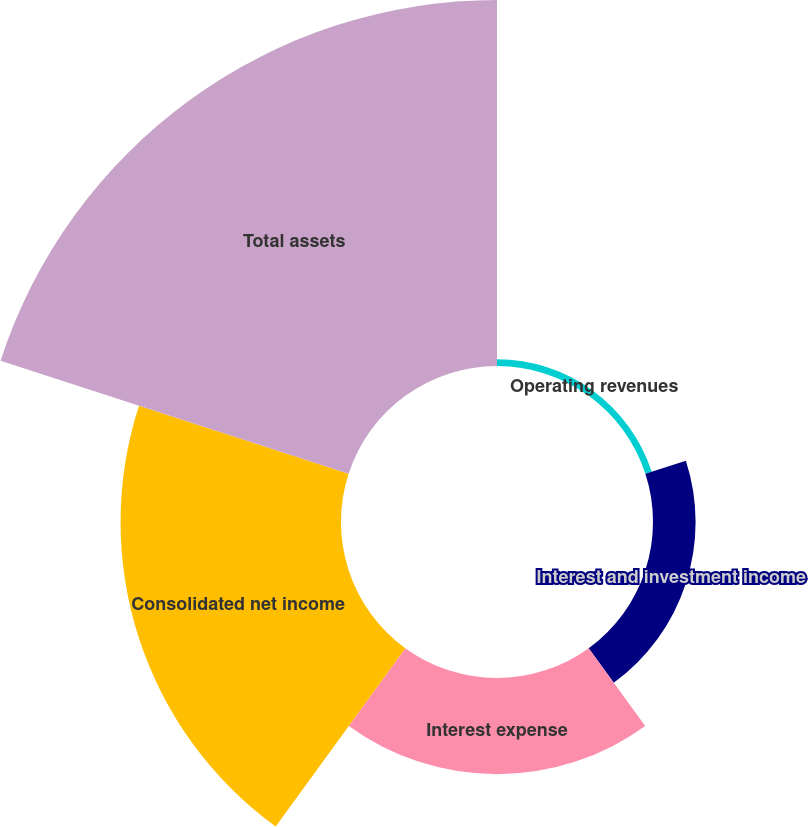<chart> <loc_0><loc_0><loc_500><loc_500><pie_chart><fcel>Operating revenues<fcel>Interest and investment income<fcel>Interest expense<fcel>Consolidated net income<fcel>Total assets<nl><fcel>0.91%<fcel>5.82%<fcel>13.14%<fcel>30.12%<fcel>50.01%<nl></chart> 